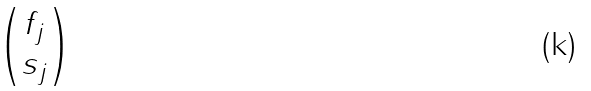Convert formula to latex. <formula><loc_0><loc_0><loc_500><loc_500>\begin{pmatrix} f _ { j } \\ s _ { j } \end{pmatrix}</formula> 